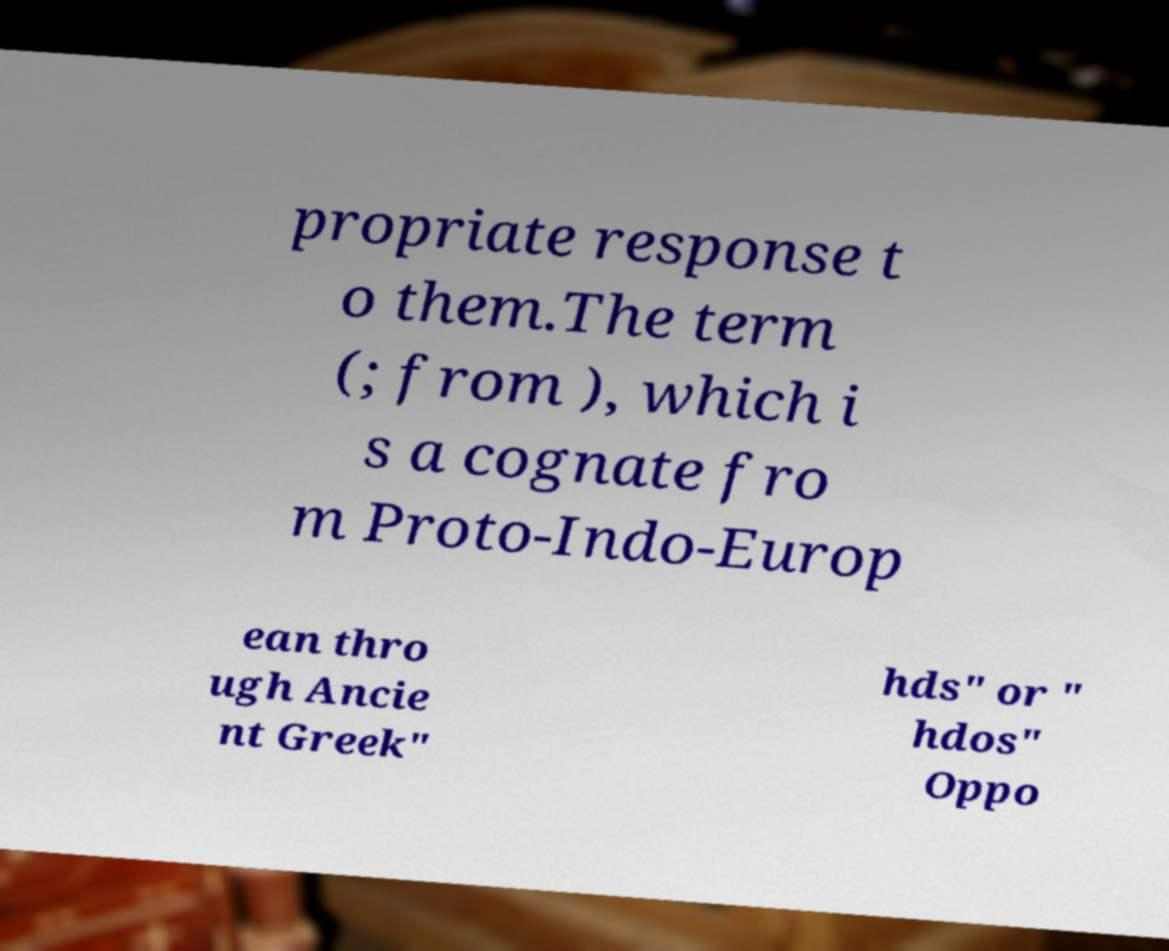Please identify and transcribe the text found in this image. propriate response t o them.The term (; from ), which i s a cognate fro m Proto-Indo-Europ ean thro ugh Ancie nt Greek" hds" or " hdos" Oppo 